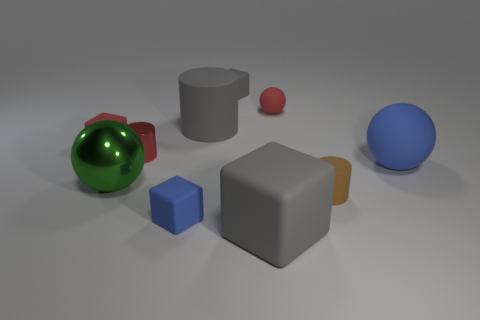Subtract all brown cubes. Subtract all yellow balls. How many cubes are left? 4 Subtract all blocks. How many objects are left? 6 Add 2 small metal cylinders. How many small metal cylinders exist? 3 Subtract 1 red cylinders. How many objects are left? 9 Subtract all small purple matte things. Subtract all blue cubes. How many objects are left? 9 Add 4 gray matte cylinders. How many gray matte cylinders are left? 5 